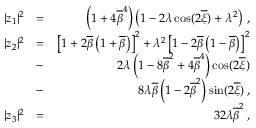<formula> <loc_0><loc_0><loc_500><loc_500>\begin{array} { r l r } { | z _ { 1 } | ^ { 2 } } & { = } & { \left ( 1 + 4 \overline { \beta } ^ { 4 } \right ) \left ( 1 - 2 \lambda \cos ( 2 \overline { \xi } ) + \lambda ^ { 2 } \right ) \, , } \\ { | z _ { 2 } | ^ { 2 } } & { = } & { \left [ 1 + 2 \overline { \beta } \left ( 1 + \overline { \beta } \right ) \right ] ^ { 2 } + \lambda ^ { 2 } \left [ 1 - 2 \overline { \beta } \left ( 1 - \overline { \beta } \right ) \right ] ^ { 2 } } \\ & { - } & { 2 \lambda \left ( 1 - 8 \overline { \beta } ^ { 2 } + 4 \overline { \beta } ^ { 4 } \right ) \cos ( 2 \overline { \xi } ) } \\ & { - } & { 8 \lambda \overline { \beta } \left ( 1 - 2 \overline { \beta } ^ { 2 } \right ) \sin ( 2 \overline { \xi } ) \, , } \\ { | z _ { 3 } | ^ { 2 } } & { = } & { 3 2 \lambda \overline { \beta } ^ { 2 } \, , } \end{array}</formula> 